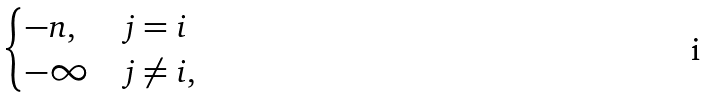<formula> <loc_0><loc_0><loc_500><loc_500>\begin{cases} - n , & j = i \\ - \infty & j \neq i , \end{cases}</formula> 